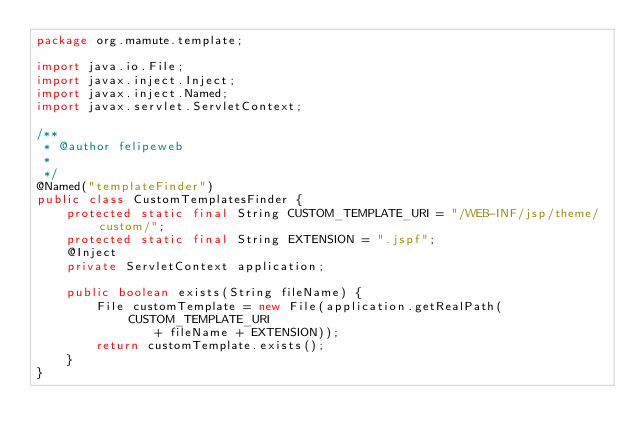<code> <loc_0><loc_0><loc_500><loc_500><_Java_>package org.mamute.template;

import java.io.File;
import javax.inject.Inject;
import javax.inject.Named;
import javax.servlet.ServletContext;

/**
 * @author felipeweb
 *
 */
@Named("templateFinder")
public class CustomTemplatesFinder {
	protected static final String CUSTOM_TEMPLATE_URI = "/WEB-INF/jsp/theme/custom/";
	protected static final String EXTENSION = ".jspf";
	@Inject
	private ServletContext application;

	public boolean exists(String fileName) {
		File customTemplate = new File(application.getRealPath(CUSTOM_TEMPLATE_URI
				+ fileName + EXTENSION));
		return customTemplate.exists();
	}
}
</code> 